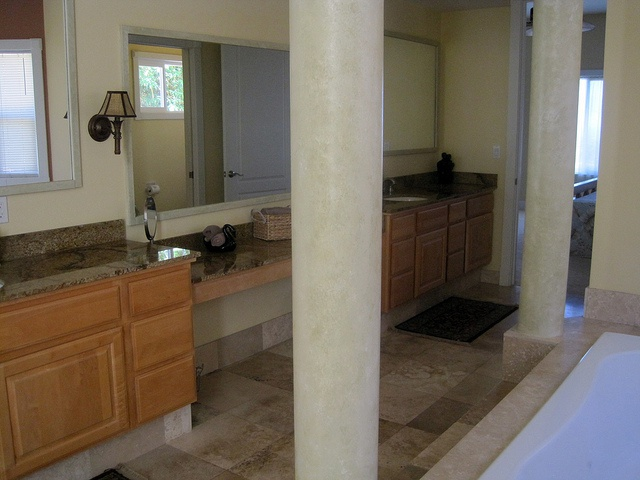Describe the objects in this image and their specific colors. I can see a sink in black and gray tones in this image. 